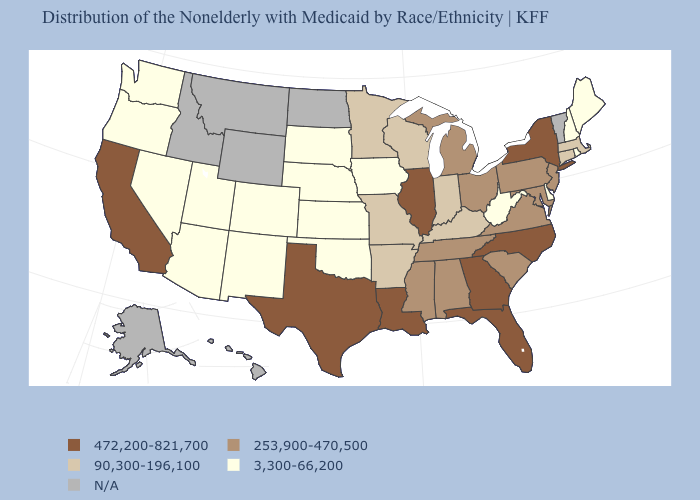What is the highest value in the West ?
Short answer required. 472,200-821,700. What is the lowest value in the West?
Keep it brief. 3,300-66,200. Among the states that border Idaho , which have the lowest value?
Short answer required. Nevada, Oregon, Utah, Washington. Name the states that have a value in the range 472,200-821,700?
Short answer required. California, Florida, Georgia, Illinois, Louisiana, New York, North Carolina, Texas. What is the value of Nevada?
Give a very brief answer. 3,300-66,200. What is the lowest value in states that border Washington?
Short answer required. 3,300-66,200. How many symbols are there in the legend?
Be succinct. 5. How many symbols are there in the legend?
Be succinct. 5. Which states have the lowest value in the Northeast?
Be succinct. Maine, New Hampshire, Rhode Island. Among the states that border Montana , which have the lowest value?
Answer briefly. South Dakota. What is the value of New Jersey?
Give a very brief answer. 253,900-470,500. Does the first symbol in the legend represent the smallest category?
Give a very brief answer. No. What is the value of Delaware?
Write a very short answer. 3,300-66,200. Name the states that have a value in the range 90,300-196,100?
Write a very short answer. Arkansas, Connecticut, Indiana, Kentucky, Massachusetts, Minnesota, Missouri, Wisconsin. Does Delaware have the lowest value in the South?
Give a very brief answer. Yes. 